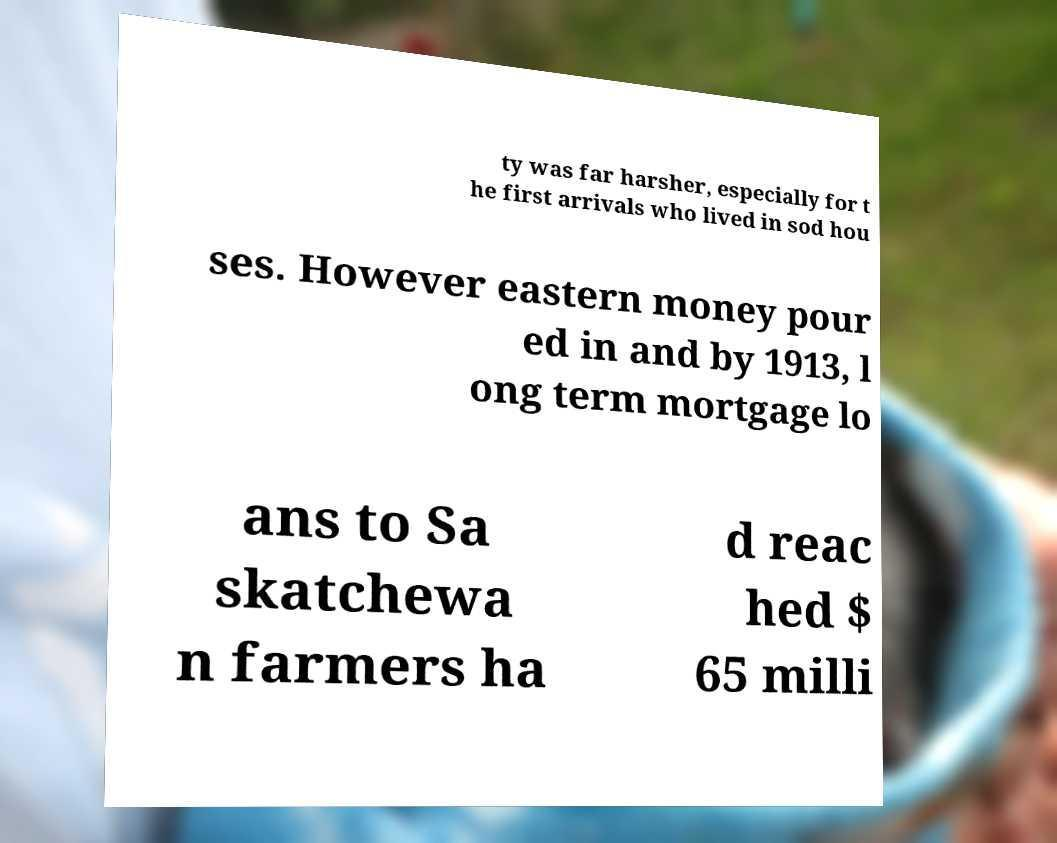What messages or text are displayed in this image? I need them in a readable, typed format. ty was far harsher, especially for t he first arrivals who lived in sod hou ses. However eastern money pour ed in and by 1913, l ong term mortgage lo ans to Sa skatchewa n farmers ha d reac hed $ 65 milli 